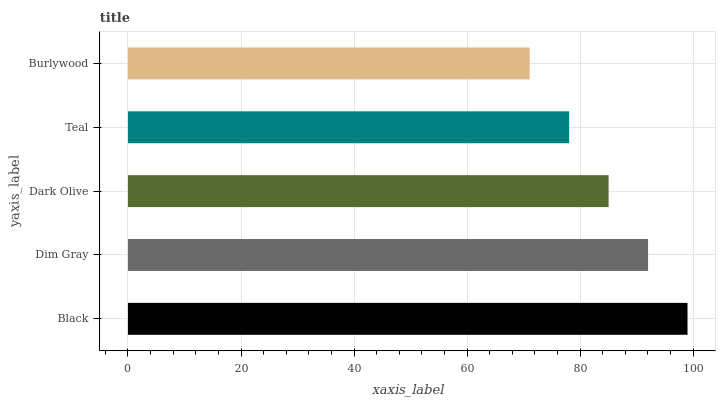Is Burlywood the minimum?
Answer yes or no. Yes. Is Black the maximum?
Answer yes or no. Yes. Is Dim Gray the minimum?
Answer yes or no. No. Is Dim Gray the maximum?
Answer yes or no. No. Is Black greater than Dim Gray?
Answer yes or no. Yes. Is Dim Gray less than Black?
Answer yes or no. Yes. Is Dim Gray greater than Black?
Answer yes or no. No. Is Black less than Dim Gray?
Answer yes or no. No. Is Dark Olive the high median?
Answer yes or no. Yes. Is Dark Olive the low median?
Answer yes or no. Yes. Is Burlywood the high median?
Answer yes or no. No. Is Dim Gray the low median?
Answer yes or no. No. 